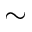Convert formula to latex. <formula><loc_0><loc_0><loc_500><loc_500>\sim</formula> 